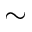Convert formula to latex. <formula><loc_0><loc_0><loc_500><loc_500>\sim</formula> 